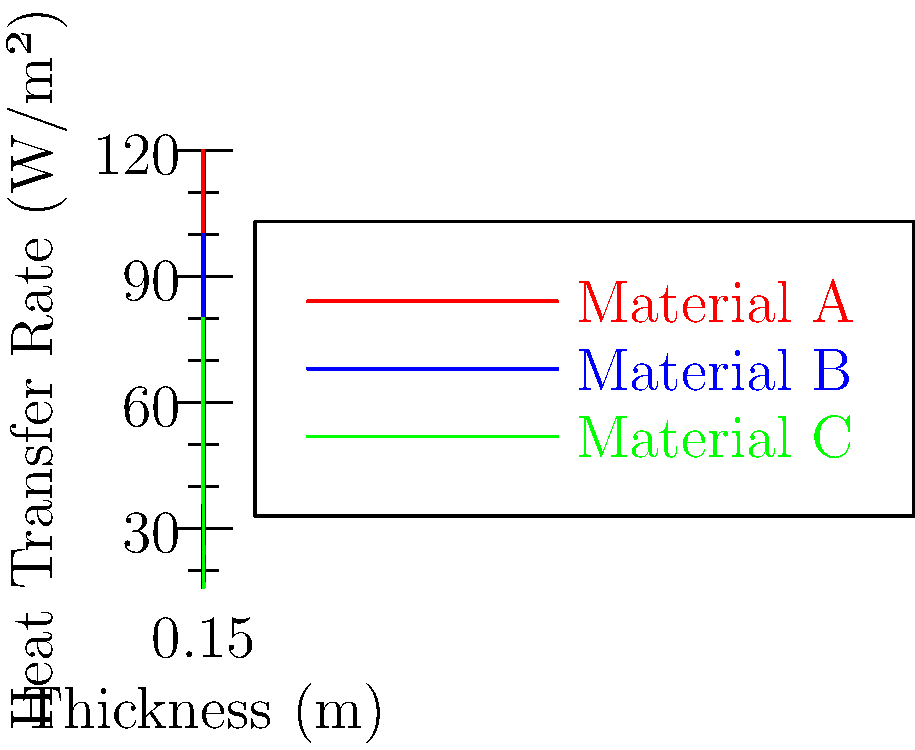As a risk management specialist analyzing investment strategies for a pension fund, you're evaluating the efficiency of different insulation materials for a new green building project. The graph shows the heat transfer rates through three insulation materials (A, B, and C) at various thicknesses. If the building code requires a heat transfer rate of no more than 30 W/m², what is the minimum thickness of Material B that meets this requirement? To solve this problem, we need to follow these steps:

1. Identify the target heat transfer rate: 30 W/m²

2. Locate this value on the y-axis of the graph.

3. Find where the line for Material B (blue line) intersects with the horizontal line at 30 W/m².

4. Read the corresponding thickness value on the x-axis.

Looking at the graph:

1. We locate 30 W/m² on the y-axis.

2. We follow this value horizontally until it intersects with the blue line (Material B).

3. The intersection point appears to be between 0.15 m and 0.20 m on the x-axis.

4. More precisely, it looks to be at approximately 0.18 m.

Therefore, the minimum thickness of Material B that achieves a heat transfer rate of 30 W/m² or less is approximately 0.18 m.

This analysis is crucial for risk management in the pension fund's investment strategy, as it helps determine the most cost-effective insulation solution that meets building code requirements, potentially leading to energy savings and increased property value over time.
Answer: 0.18 m 